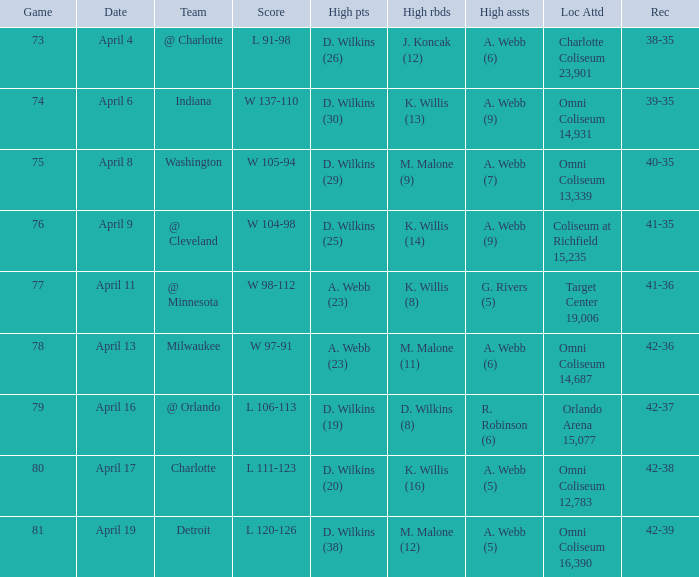Where was the location and attendance when they played milwaukee? Omni Coliseum 14,687. Would you be able to parse every entry in this table? {'header': ['Game', 'Date', 'Team', 'Score', 'High pts', 'High rbds', 'High assts', 'Loc Attd', 'Rec'], 'rows': [['73', 'April 4', '@ Charlotte', 'L 91-98', 'D. Wilkins (26)', 'J. Koncak (12)', 'A. Webb (6)', 'Charlotte Coliseum 23,901', '38-35'], ['74', 'April 6', 'Indiana', 'W 137-110', 'D. Wilkins (30)', 'K. Willis (13)', 'A. Webb (9)', 'Omni Coliseum 14,931', '39-35'], ['75', 'April 8', 'Washington', 'W 105-94', 'D. Wilkins (29)', 'M. Malone (9)', 'A. Webb (7)', 'Omni Coliseum 13,339', '40-35'], ['76', 'April 9', '@ Cleveland', 'W 104-98', 'D. Wilkins (25)', 'K. Willis (14)', 'A. Webb (9)', 'Coliseum at Richfield 15,235', '41-35'], ['77', 'April 11', '@ Minnesota', 'W 98-112', 'A. Webb (23)', 'K. Willis (8)', 'G. Rivers (5)', 'Target Center 19,006', '41-36'], ['78', 'April 13', 'Milwaukee', 'W 97-91', 'A. Webb (23)', 'M. Malone (11)', 'A. Webb (6)', 'Omni Coliseum 14,687', '42-36'], ['79', 'April 16', '@ Orlando', 'L 106-113', 'D. Wilkins (19)', 'D. Wilkins (8)', 'R. Robinson (6)', 'Orlando Arena 15,077', '42-37'], ['80', 'April 17', 'Charlotte', 'L 111-123', 'D. Wilkins (20)', 'K. Willis (16)', 'A. Webb (5)', 'Omni Coliseum 12,783', '42-38'], ['81', 'April 19', 'Detroit', 'L 120-126', 'D. Wilkins (38)', 'M. Malone (12)', 'A. Webb (5)', 'Omni Coliseum 16,390', '42-39']]} 